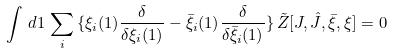<formula> <loc_0><loc_0><loc_500><loc_500>\int \, d 1 \, \sum _ { i } \, \{ \xi _ { i } ( 1 ) \frac { \delta } { \delta \xi _ { i } ( 1 ) } - \bar { \xi } _ { i } ( 1 ) \frac { \delta } { \delta \bar { \xi } _ { i } ( 1 ) } \} \, \tilde { Z } [ J , \hat { J } , \bar { \xi } , \xi ] = 0</formula> 